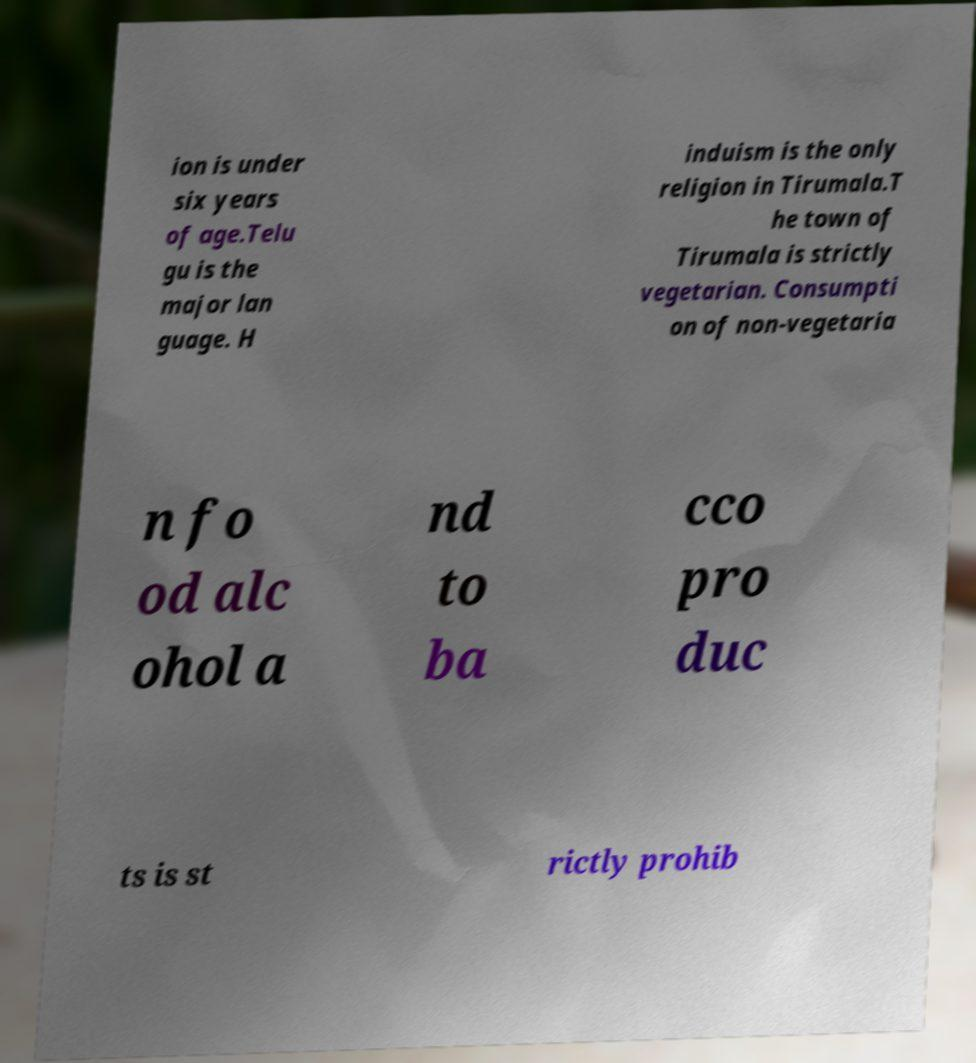For documentation purposes, I need the text within this image transcribed. Could you provide that? ion is under six years of age.Telu gu is the major lan guage. H induism is the only religion in Tirumala.T he town of Tirumala is strictly vegetarian. Consumpti on of non-vegetaria n fo od alc ohol a nd to ba cco pro duc ts is st rictly prohib 